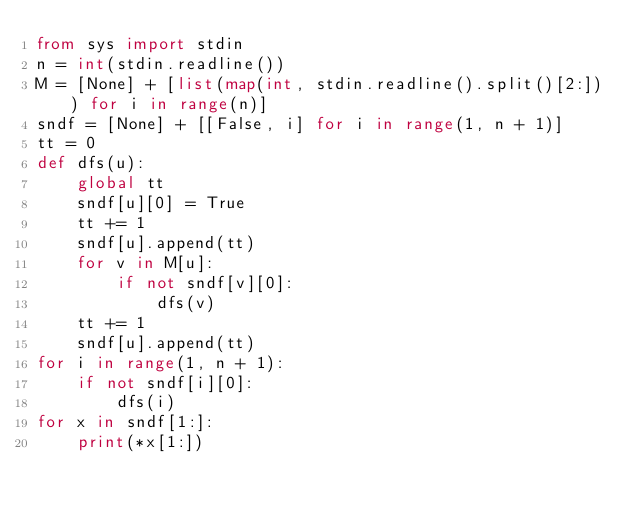<code> <loc_0><loc_0><loc_500><loc_500><_Python_>from sys import stdin
n = int(stdin.readline())
M = [None] + [list(map(int, stdin.readline().split()[2:])) for i in range(n)]
sndf = [None] + [[False, i] for i in range(1, n + 1)]
tt = 0
def dfs(u):
    global tt
    sndf[u][0] = True
    tt += 1
    sndf[u].append(tt)
    for v in M[u]:
        if not sndf[v][0]:
            dfs(v)
    tt += 1
    sndf[u].append(tt)
for i in range(1, n + 1):
    if not sndf[i][0]:
        dfs(i)
for x in sndf[1:]:
    print(*x[1:])</code> 